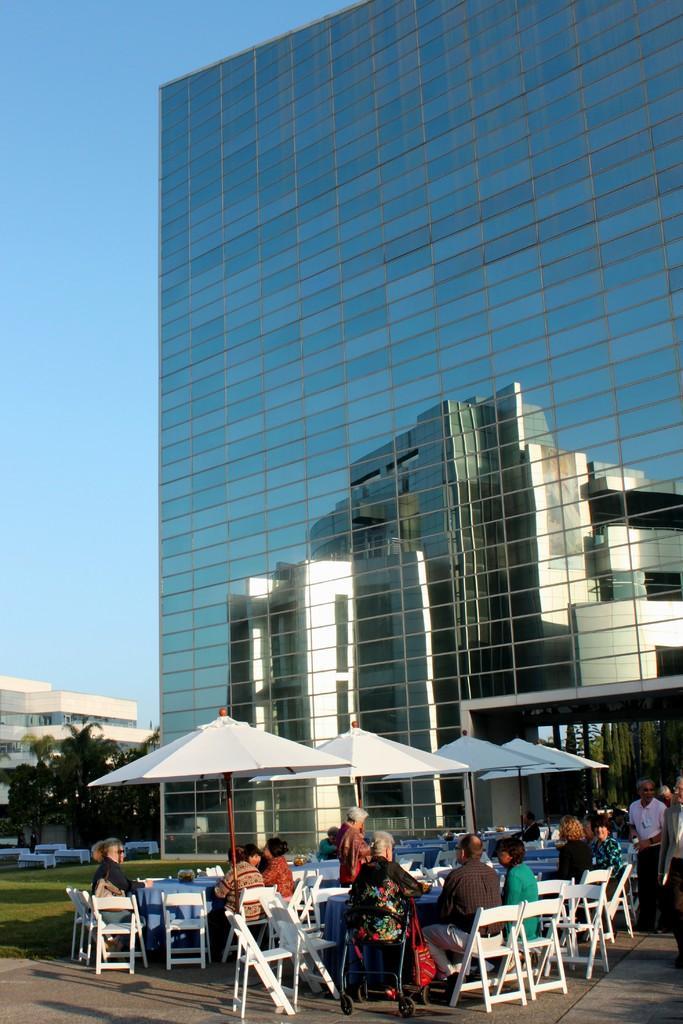Describe this image in one or two sentences. Bottom of the image few people sitting on the chairs. In the middle of the image there are some umbrellas. Bottom right side of the image few men are walking. Bottom left side of the image there is a grass and there are some trees. Top right side of the image there is a building. Top left side of the image there is a sky. 